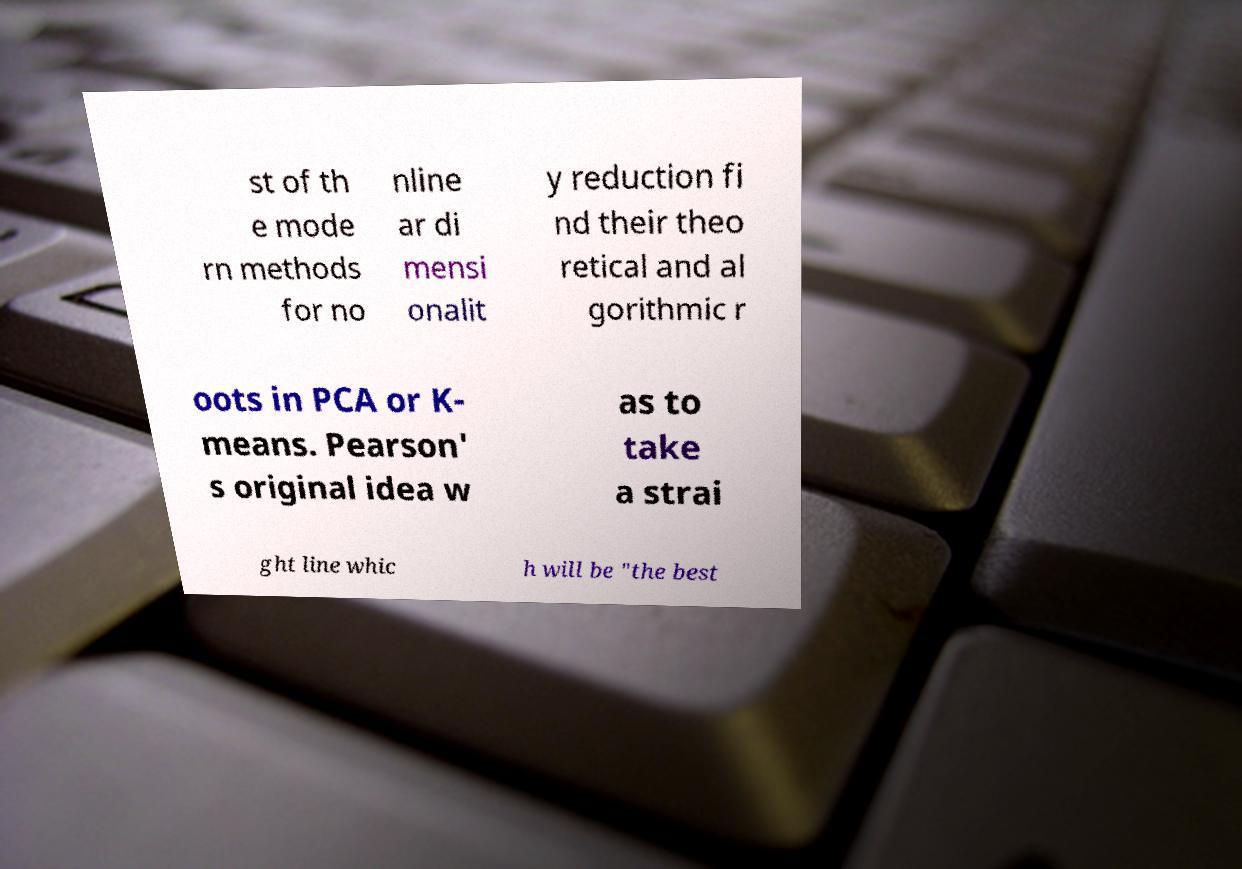Can you read and provide the text displayed in the image?This photo seems to have some interesting text. Can you extract and type it out for me? st of th e mode rn methods for no nline ar di mensi onalit y reduction fi nd their theo retical and al gorithmic r oots in PCA or K- means. Pearson' s original idea w as to take a strai ght line whic h will be "the best 